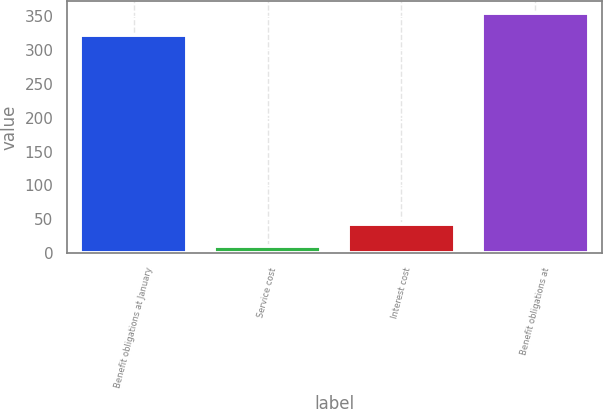Convert chart. <chart><loc_0><loc_0><loc_500><loc_500><bar_chart><fcel>Benefit obligations at January<fcel>Service cost<fcel>Interest cost<fcel>Benefit obligations at<nl><fcel>322<fcel>11<fcel>43.7<fcel>354.7<nl></chart> 